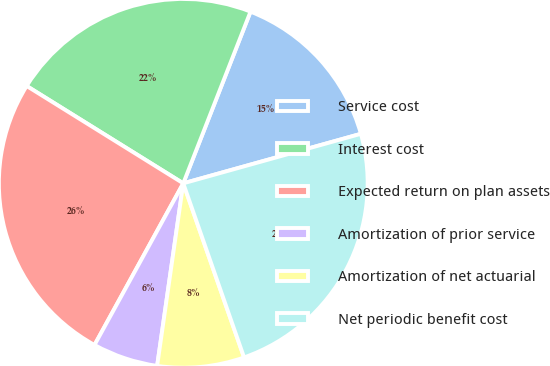<chart> <loc_0><loc_0><loc_500><loc_500><pie_chart><fcel>Service cost<fcel>Interest cost<fcel>Expected return on plan assets<fcel>Amortization of prior service<fcel>Amortization of net actuarial<fcel>Net periodic benefit cost<nl><fcel>14.73%<fcel>22.09%<fcel>25.86%<fcel>5.73%<fcel>7.61%<fcel>23.98%<nl></chart> 